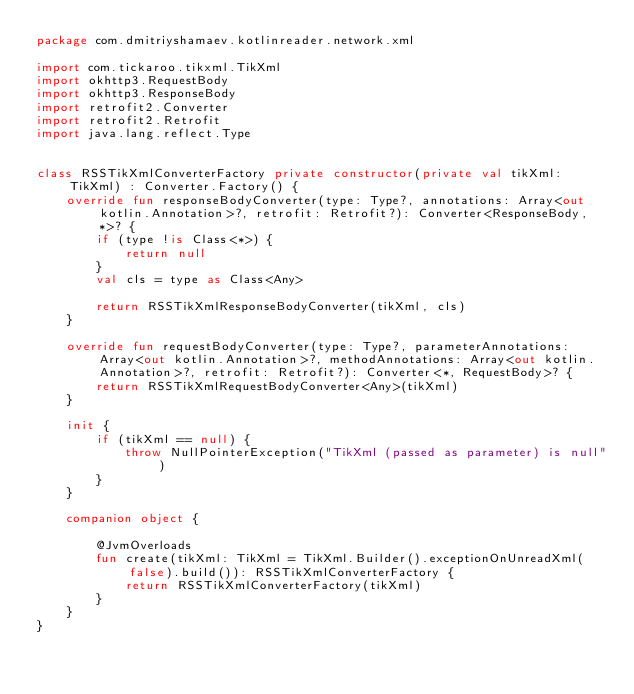Convert code to text. <code><loc_0><loc_0><loc_500><loc_500><_Kotlin_>package com.dmitriyshamaev.kotlinreader.network.xml

import com.tickaroo.tikxml.TikXml
import okhttp3.RequestBody
import okhttp3.ResponseBody
import retrofit2.Converter
import retrofit2.Retrofit
import java.lang.reflect.Type


class RSSTikXmlConverterFactory private constructor(private val tikXml: TikXml) : Converter.Factory() {
    override fun responseBodyConverter(type: Type?, annotations: Array<out kotlin.Annotation>?, retrofit: Retrofit?): Converter<ResponseBody, *>? {
        if (type !is Class<*>) {
            return null
        }
        val cls = type as Class<Any>

        return RSSTikXmlResponseBodyConverter(tikXml, cls)
    }

    override fun requestBodyConverter(type: Type?, parameterAnnotations: Array<out kotlin.Annotation>?, methodAnnotations: Array<out kotlin.Annotation>?, retrofit: Retrofit?): Converter<*, RequestBody>? {
        return RSSTikXmlRequestBodyConverter<Any>(tikXml)
    }

    init {
        if (tikXml == null) {
            throw NullPointerException("TikXml (passed as parameter) is null")
        }
    }

    companion object {

        @JvmOverloads
        fun create(tikXml: TikXml = TikXml.Builder().exceptionOnUnreadXml(false).build()): RSSTikXmlConverterFactory {
            return RSSTikXmlConverterFactory(tikXml)
        }
    }
}</code> 